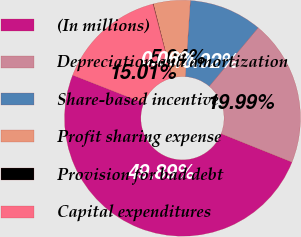Convert chart. <chart><loc_0><loc_0><loc_500><loc_500><pie_chart><fcel>(In millions)<fcel>Depreciation and amortization<fcel>Share-based incentive<fcel>Profit sharing expense<fcel>Provision for bad debt<fcel>Capital expenditures<nl><fcel>49.89%<fcel>19.99%<fcel>10.02%<fcel>5.04%<fcel>0.06%<fcel>15.01%<nl></chart> 